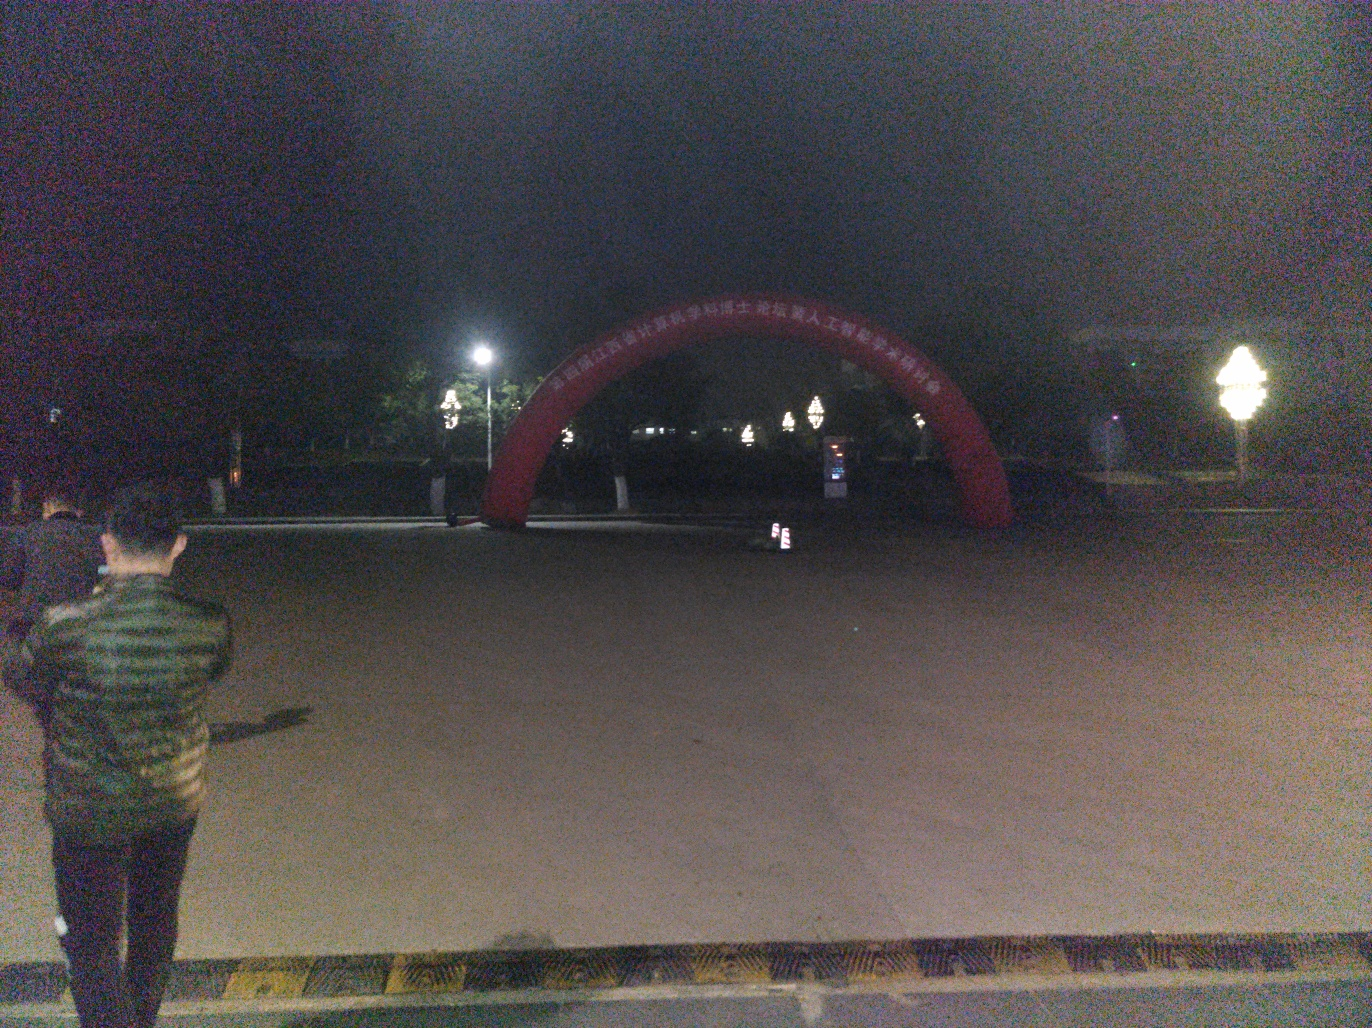Can you tell me what the red structure in the background is? It appears to be an arch-like installation, possibly used for events or as a decorative element in a public space. The inscriptions on it are not clearly visible due to the lighting, but such structures often commemorate important events or serve as a landmark. 